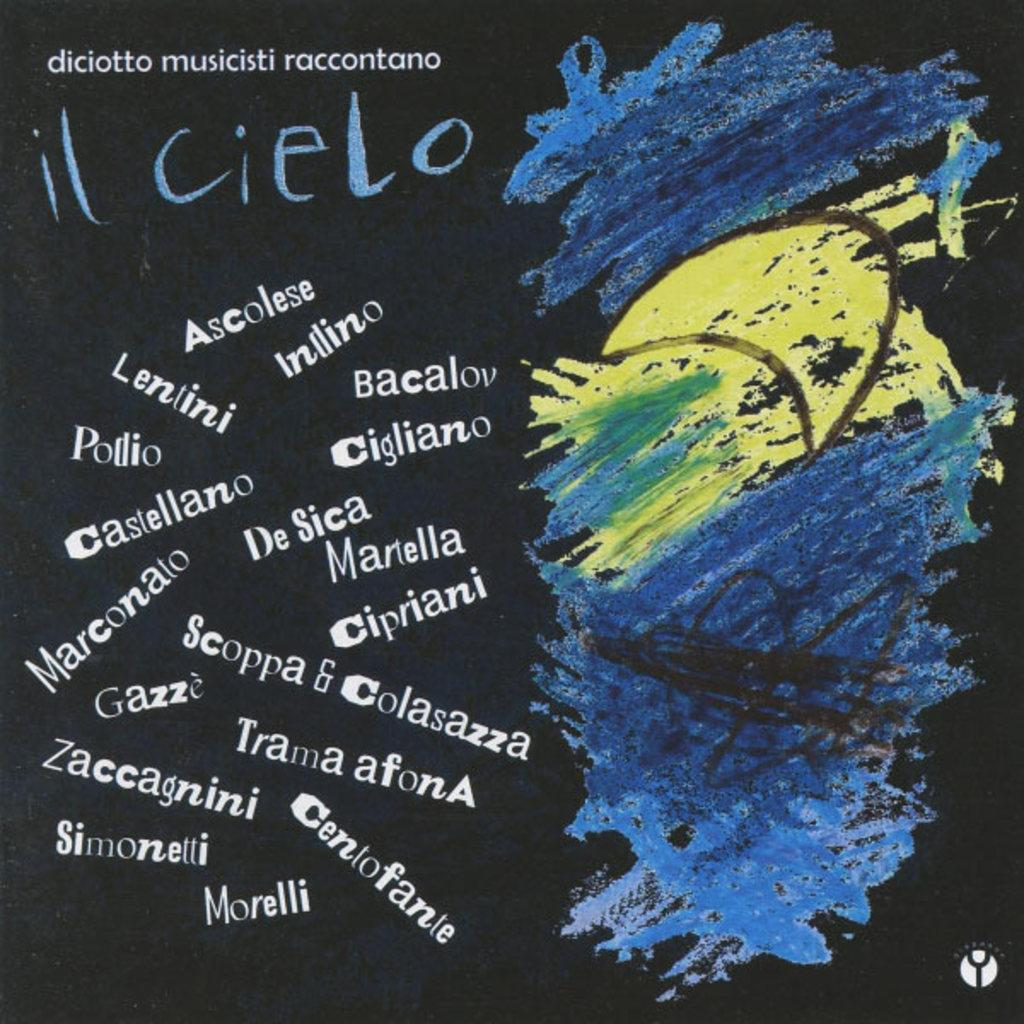What has been done to the image? The image has been edited. What else can be found in the image besides the edited content? There is text and a painting in the image. Can you describe the painting in the image? The painting is blue and yellow in color. How many spoons are visible in the painting? There are no spoons visible in the painting; it is a blue and yellow painting without any utensils. 